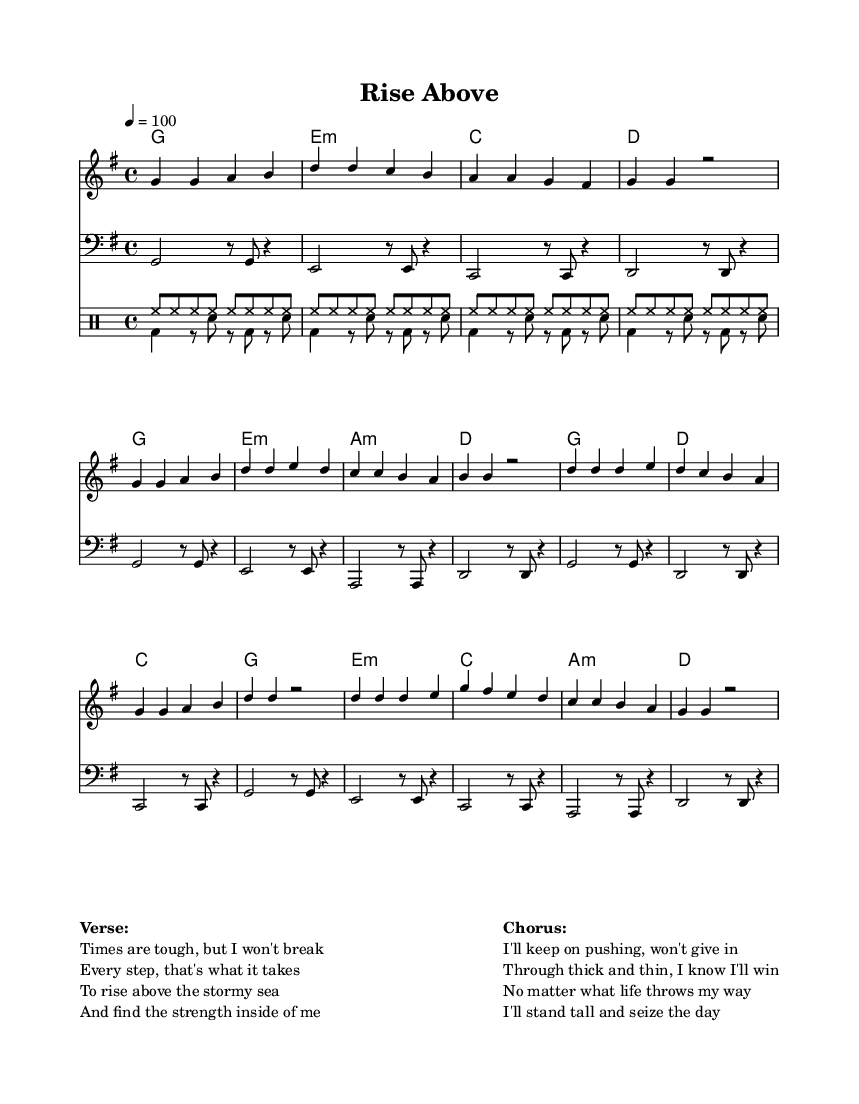What is the key signature of this music? The key signature indicates the key of G major, which has one sharp. This can be identified by looking at the key signature indicated at the beginning of the sheet music.
Answer: G major What is the time signature of the piece? The time signature is shown at the beginning of the score as 4/4, which means there are four beats in each measure and a quarter note gets one beat.
Answer: 4/4 What is the tempo marking for the song? The tempo marking is indicated as 4 = 100, meaning there are 100 beats per minute when counting quarter notes. This is located near the beginning of the score.
Answer: 100 How many measures are present in the verse section? By counting the groupings of the notes and rests in the verse section (noting that a measure contains 4 beats), we find there are 8 measures in total.
Answer: 8 What is the main theme expressed in the chorus? The chorus emphasizes determination and resilience, as seen in the lyrics, which discuss pushing through challenges and standing tall in the face of adversity.
Answer: Determination Are there any minor chords in the harmony section? Yes, there are minor chords present in the harmony section, specifically e minor and a minor, which can be found in the chord progression for the verse and chorus.
Answer: Yes What type of rhythmic instrument is prominently featured in this music? The most prominent rhythmic instrument in the piece is the drums, specifically using a hi-hat and a bass drum to create the underlying groove typical of R&B music.
Answer: Drums 